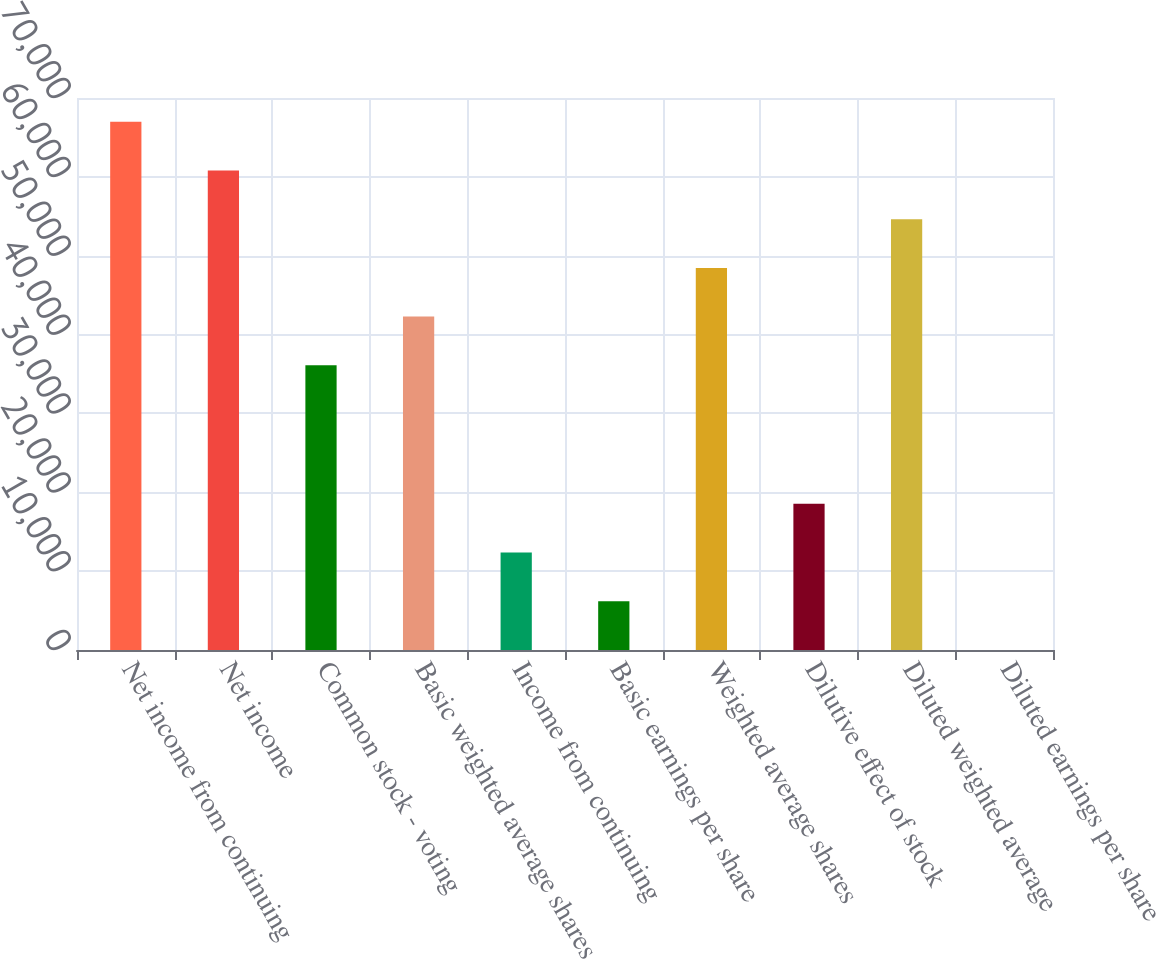<chart> <loc_0><loc_0><loc_500><loc_500><bar_chart><fcel>Net income from continuing<fcel>Net income<fcel>Common stock - voting<fcel>Basic weighted average shares<fcel>Income from continuing<fcel>Basic earnings per share<fcel>Weighted average shares<fcel>Dilutive effect of stock<fcel>Diluted weighted average<fcel>Diluted earnings per share<nl><fcel>66992.2<fcel>60814<fcel>36101<fcel>42279.2<fcel>12358.1<fcel>6179.83<fcel>48457.5<fcel>18536.3<fcel>54635.7<fcel>1.59<nl></chart> 